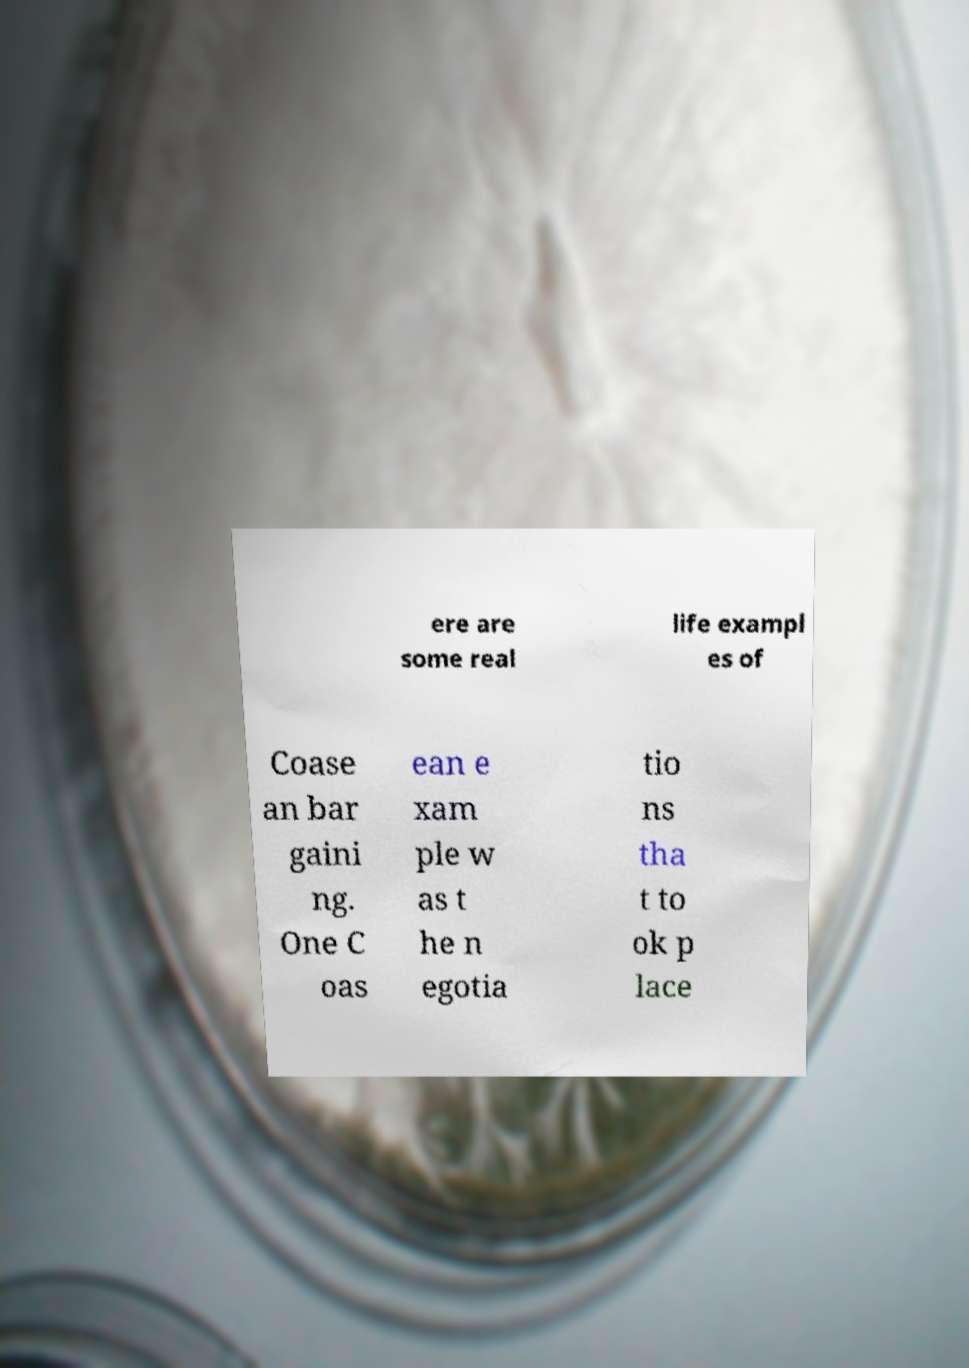For documentation purposes, I need the text within this image transcribed. Could you provide that? ere are some real life exampl es of Coase an bar gaini ng. One C oas ean e xam ple w as t he n egotia tio ns tha t to ok p lace 